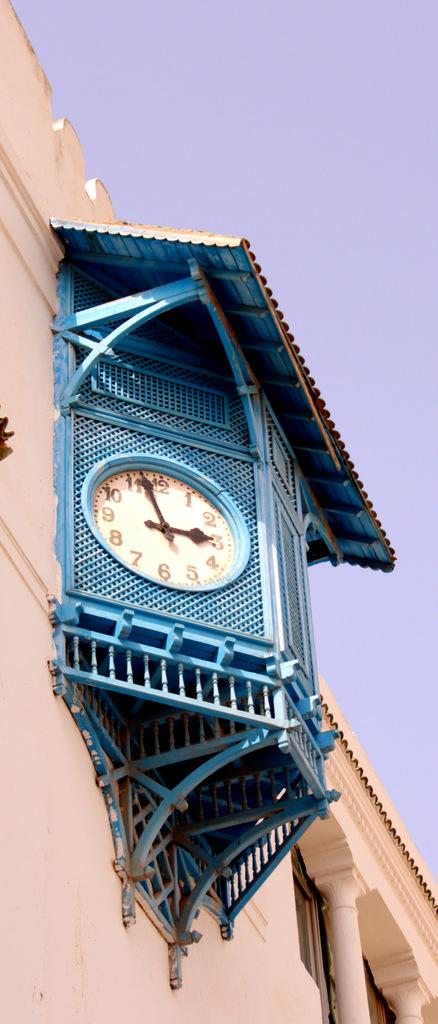<image>
Render a clear and concise summary of the photo. a clock set at 2:56 under a blue awning 